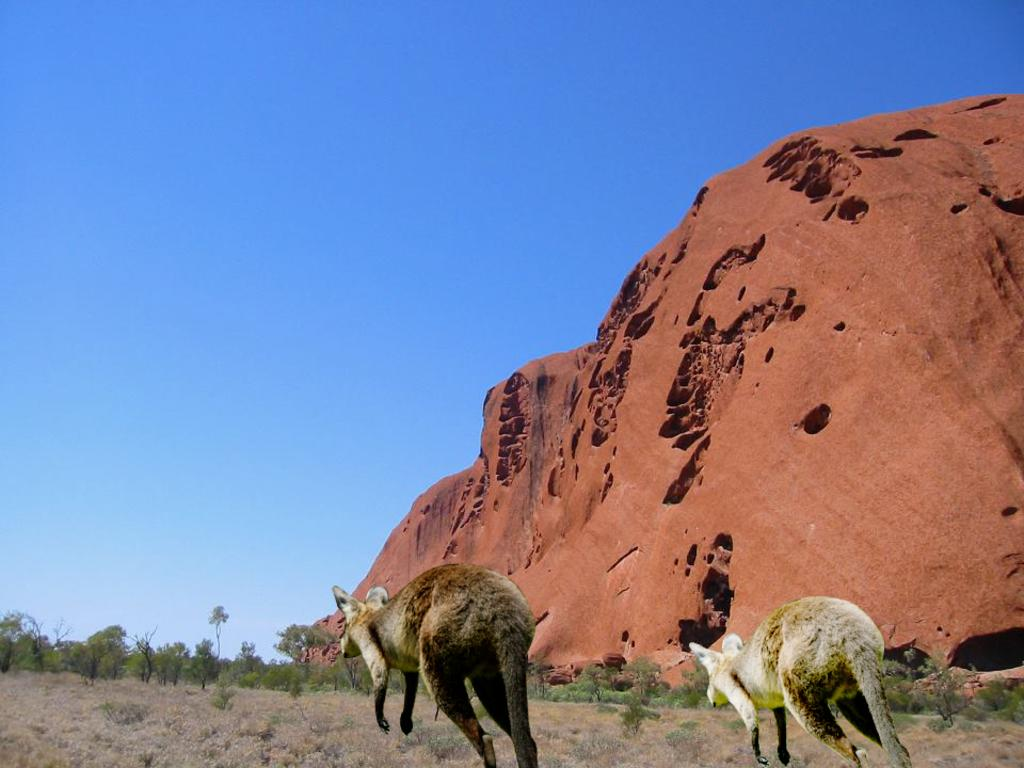What animals are in the foreground of the image? There are kangaroos in the foreground of the image. What type of vegetation can be seen in the image? There are trees in the image. What geographical feature is visible in the background of the image? The image appears to depict a mountain in the background. What part of the natural environment is visible in the image? The sky is visible in the background of the image. What type of sheet is draped over the kangaroo in the image? There is no sheet present in the image; the kangaroos are not covered or draped with any fabric. 